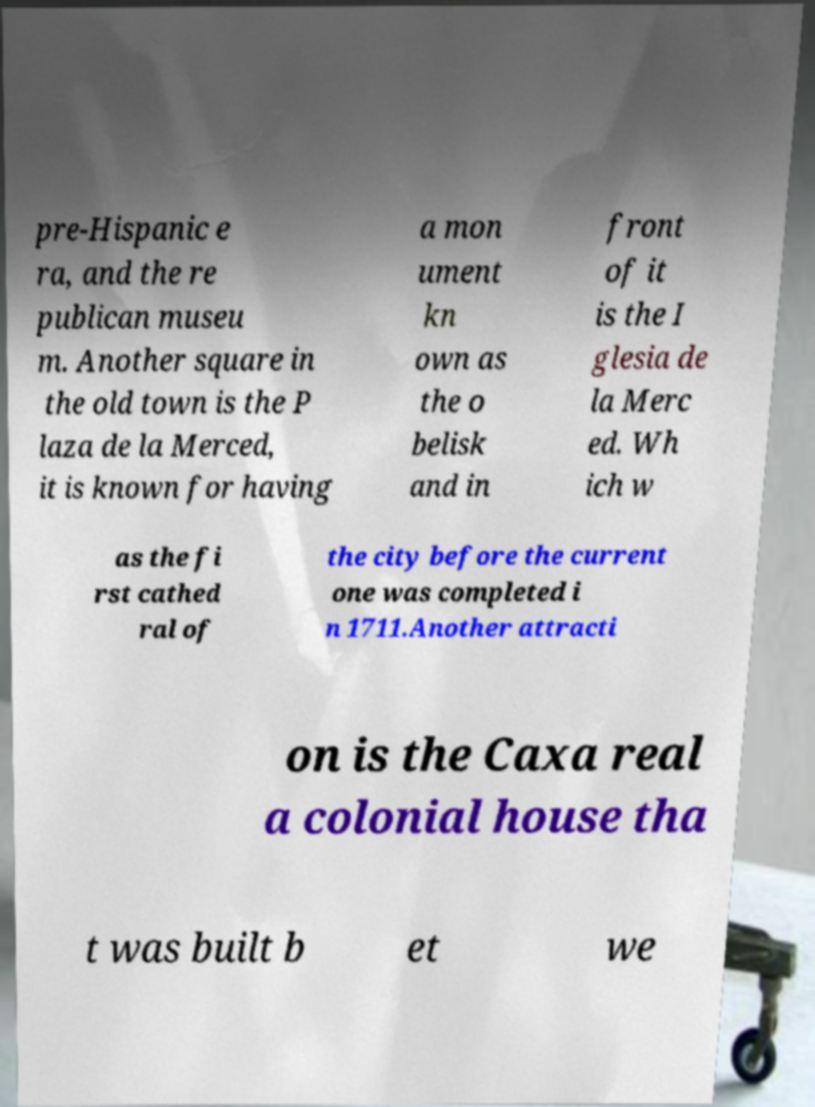Could you extract and type out the text from this image? pre-Hispanic e ra, and the re publican museu m. Another square in the old town is the P laza de la Merced, it is known for having a mon ument kn own as the o belisk and in front of it is the I glesia de la Merc ed. Wh ich w as the fi rst cathed ral of the city before the current one was completed i n 1711.Another attracti on is the Caxa real a colonial house tha t was built b et we 